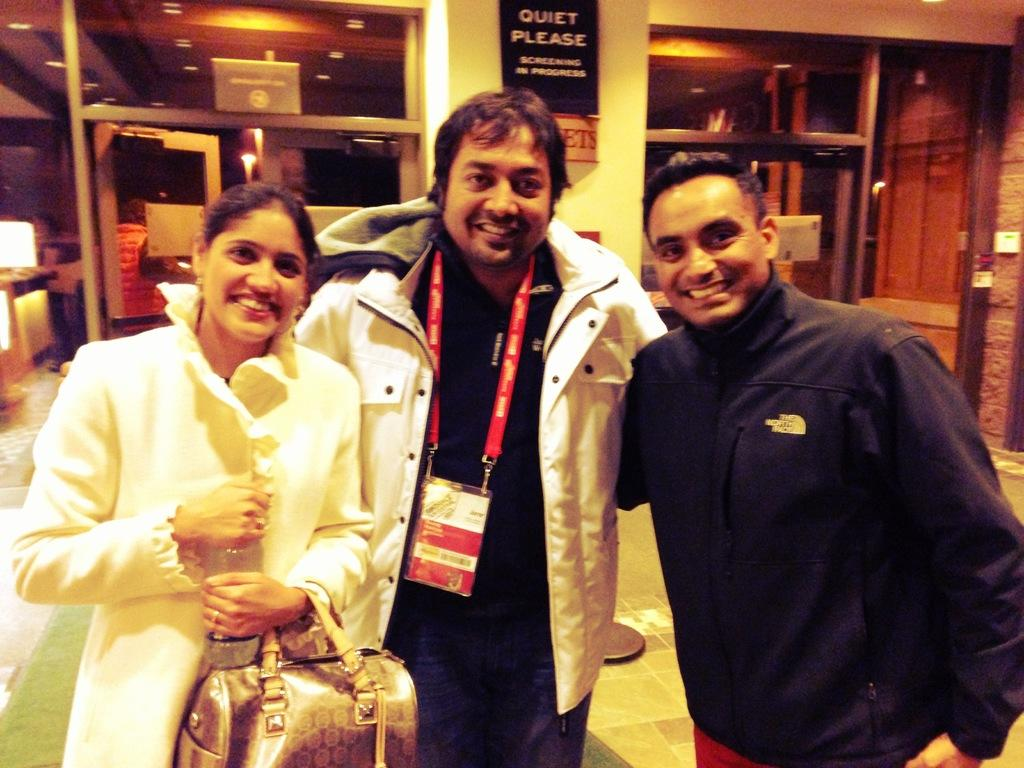How many people are in the image? There are two men and one woman in the image. What is the woman holding in the image? The woman is holding a bottle. What else is the woman carrying in the image? The woman is carrying a bag. What is the general expression of the people in the image? The people in the image are smiling. What can be seen in the background of the image? There is a pillar, a banner, a wall, and a pipe in the background of the image. What type of wheel can be seen in the image? There is no wheel present in the image. Can you hear the woman speaking in the image? The image is a still photograph, so it does not contain any sound or audio. 